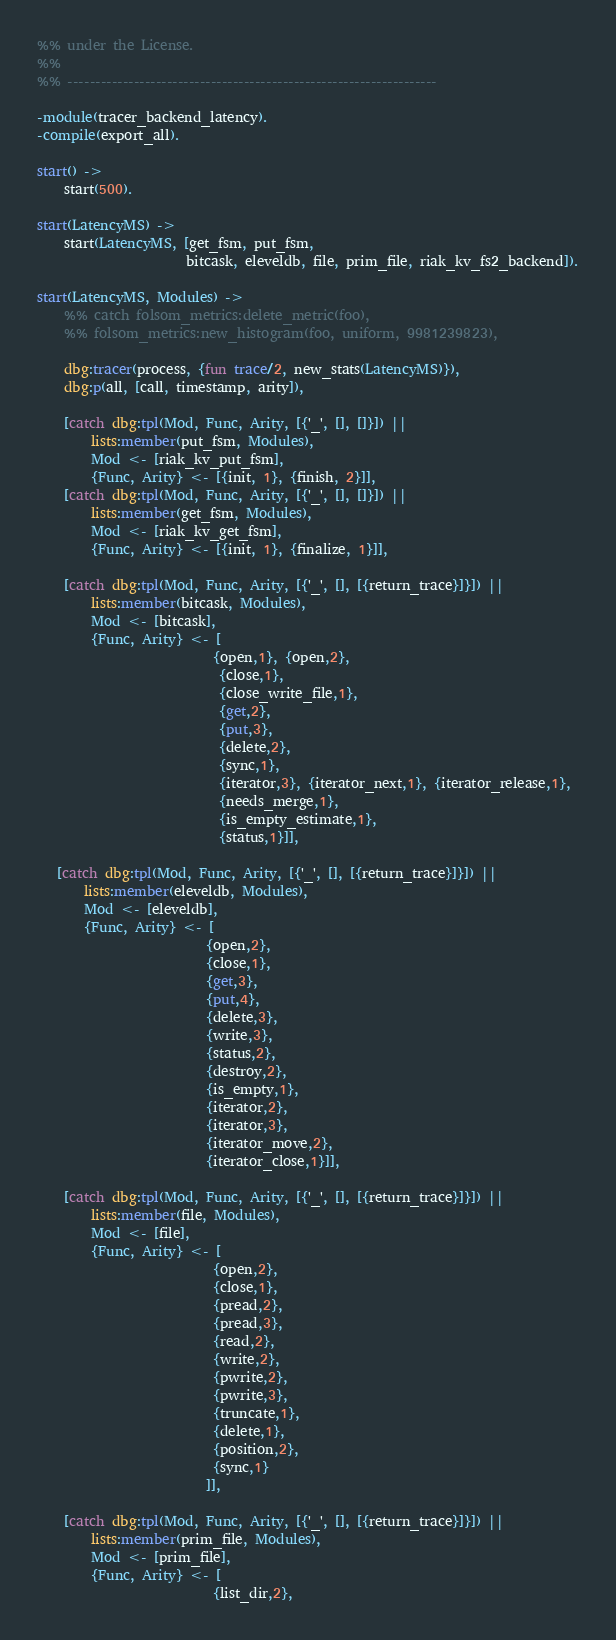<code> <loc_0><loc_0><loc_500><loc_500><_Erlang_>%% under the License.
%%
%% -------------------------------------------------------------------

-module(tracer_backend_latency).
-compile(export_all).

start() ->
    start(500).

start(LatencyMS) ->
    start(LatencyMS, [get_fsm, put_fsm,
                      bitcask, eleveldb, file, prim_file, riak_kv_fs2_backend]).

start(LatencyMS, Modules) ->
    %% catch folsom_metrics:delete_metric(foo),
    %% folsom_metrics:new_histogram(foo, uniform, 9981239823),

    dbg:tracer(process, {fun trace/2, new_stats(LatencyMS)}),
    dbg:p(all, [call, timestamp, arity]),

    [catch dbg:tpl(Mod, Func, Arity, [{'_', [], []}]) ||
        lists:member(put_fsm, Modules),
        Mod <- [riak_kv_put_fsm],
        {Func, Arity} <- [{init, 1}, {finish, 2}]],
    [catch dbg:tpl(Mod, Func, Arity, [{'_', [], []}]) ||
        lists:member(get_fsm, Modules),
        Mod <- [riak_kv_get_fsm],
        {Func, Arity} <- [{init, 1}, {finalize, 1}]],

    [catch dbg:tpl(Mod, Func, Arity, [{'_', [], [{return_trace}]}]) ||
        lists:member(bitcask, Modules),
        Mod <- [bitcask],
        {Func, Arity} <- [
                          {open,1}, {open,2},
                           {close,1},
                           {close_write_file,1},
                           {get,2},
                           {put,3},
                           {delete,2},
                           {sync,1},
                           {iterator,3}, {iterator_next,1}, {iterator_release,1},
                           {needs_merge,1},
                           {is_empty_estimate,1},
                           {status,1}]],

   [catch dbg:tpl(Mod, Func, Arity, [{'_', [], [{return_trace}]}]) ||
       lists:member(eleveldb, Modules),
       Mod <- [eleveldb],
       {Func, Arity} <- [
                         {open,2},
                         {close,1},
                         {get,3},
                         {put,4},
                         {delete,3},
                         {write,3},
                         {status,2},
                         {destroy,2},
                         {is_empty,1},
                         {iterator,2},
                         {iterator,3},
                         {iterator_move,2},
                         {iterator_close,1}]],

    [catch dbg:tpl(Mod, Func, Arity, [{'_', [], [{return_trace}]}]) ||
        lists:member(file, Modules),
        Mod <- [file],
        {Func, Arity} <- [
                          {open,2},
                          {close,1},
                          {pread,2},
                          {pread,3},
                          {read,2},
                          {write,2},
                          {pwrite,2},
                          {pwrite,3},
                          {truncate,1},
                          {delete,1},
                          {position,2},
                          {sync,1}
                         ]],

    [catch dbg:tpl(Mod, Func, Arity, [{'_', [], [{return_trace}]}]) ||
        lists:member(prim_file, Modules),
        Mod <- [prim_file],
        {Func, Arity} <- [
                          {list_dir,2},</code> 